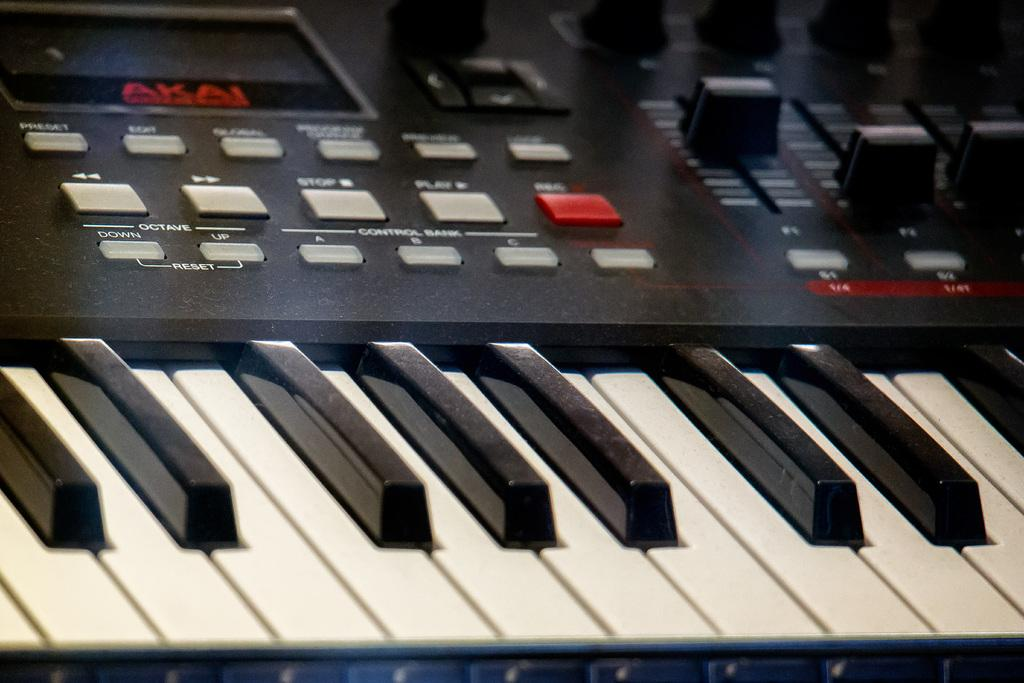<image>
Render a clear and concise summary of the photo. A electronic keyboard has various buttons, including some labeled for changing the octave up or down. 